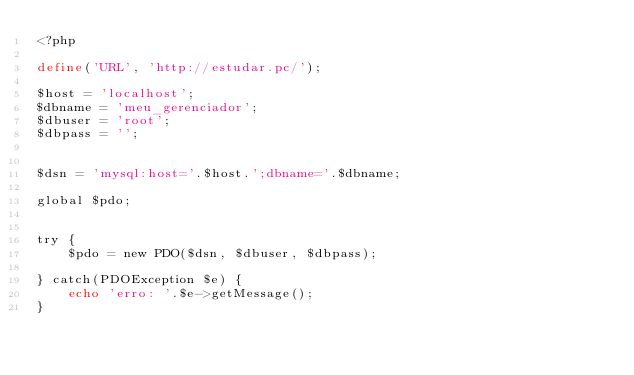<code> <loc_0><loc_0><loc_500><loc_500><_PHP_><?php

define('URL', 'http://estudar.pc/');

$host = 'localhost';
$dbname = 'meu_gerenciador';
$dbuser = 'root';
$dbpass = '';


$dsn = 'mysql:host='.$host.';dbname='.$dbname;

global $pdo;


try {
    $pdo = new PDO($dsn, $dbuser, $dbpass);

} catch(PDOException $e) {
    echo 'erro: '.$e->getMessage();
}
</code> 